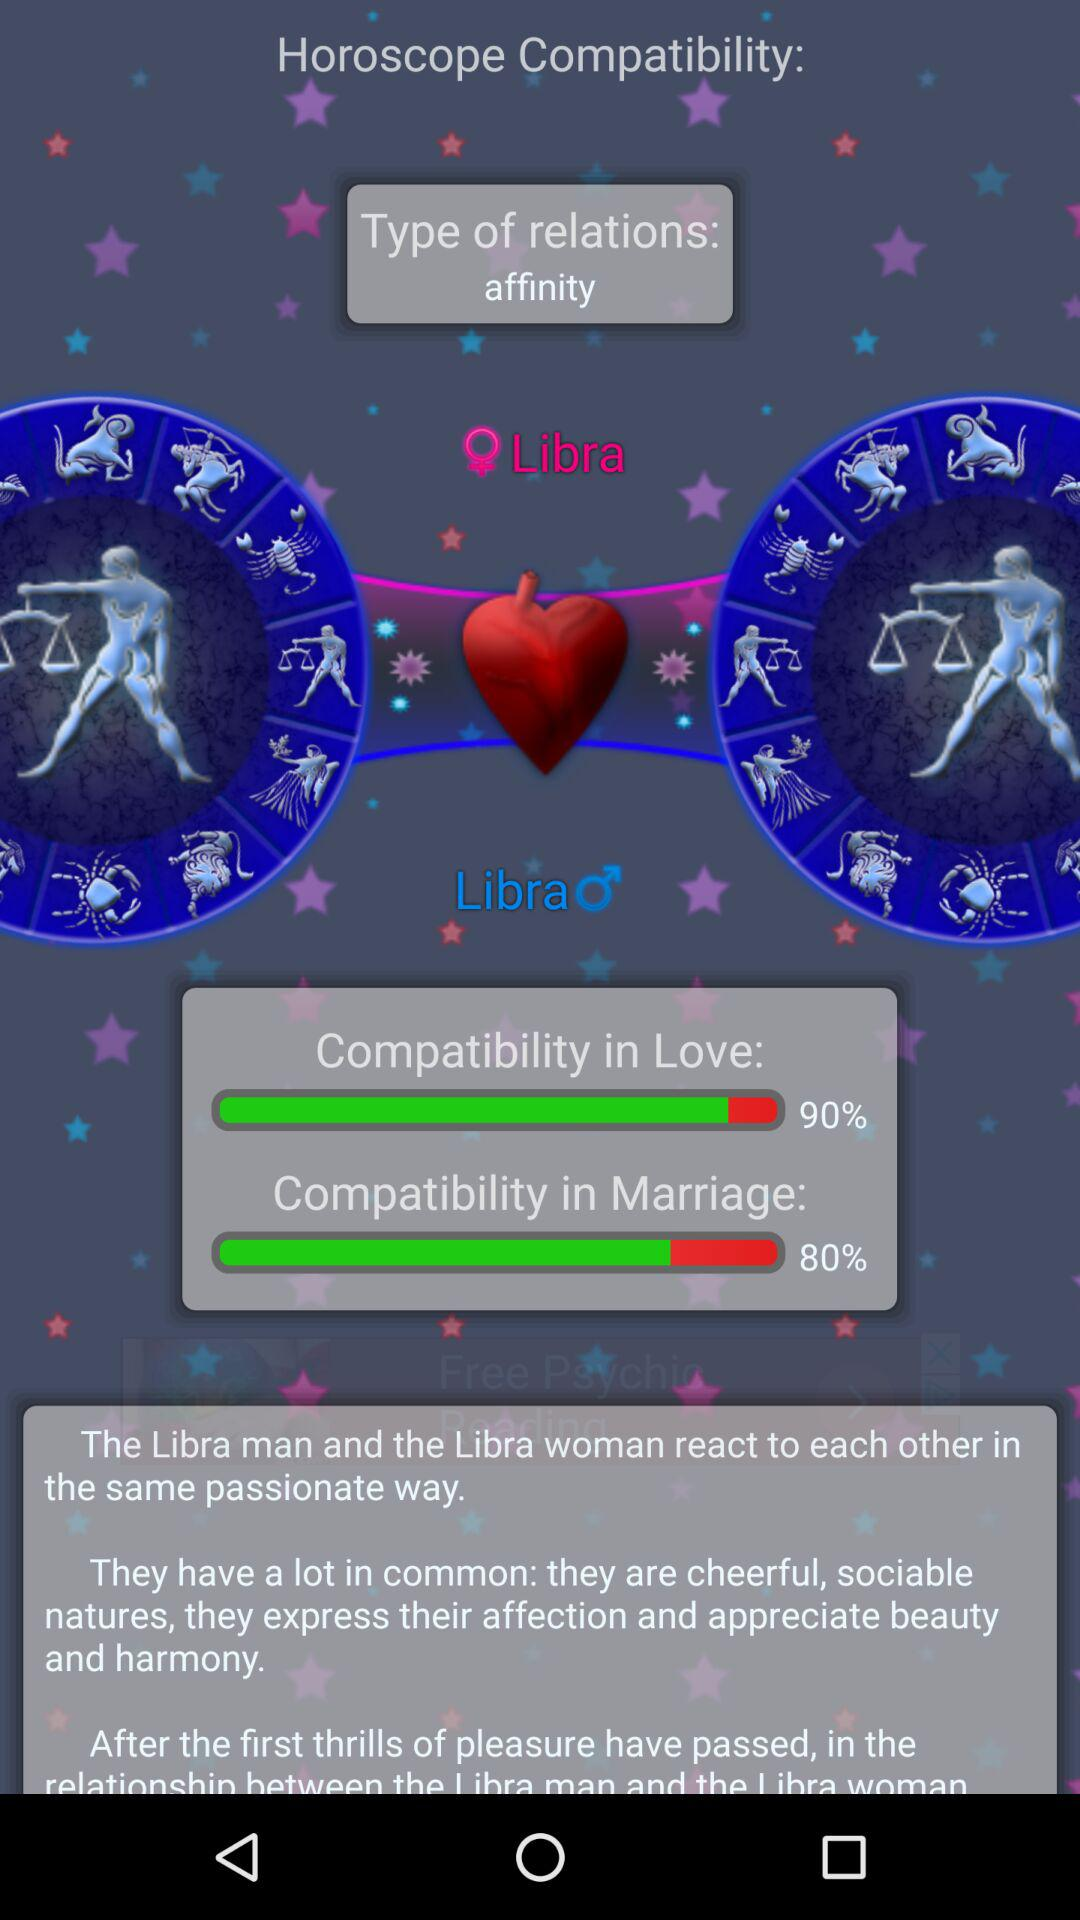What is the "Horoscope Compatibility" percentage?
When the provided information is insufficient, respond with <no answer>. <no answer> 